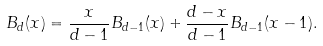<formula> <loc_0><loc_0><loc_500><loc_500>B _ { d } ( x ) = \frac { x } { d - 1 } B _ { d - 1 } ( x ) + \frac { d - x } { d - 1 } B _ { d - 1 } ( x - 1 ) .</formula> 